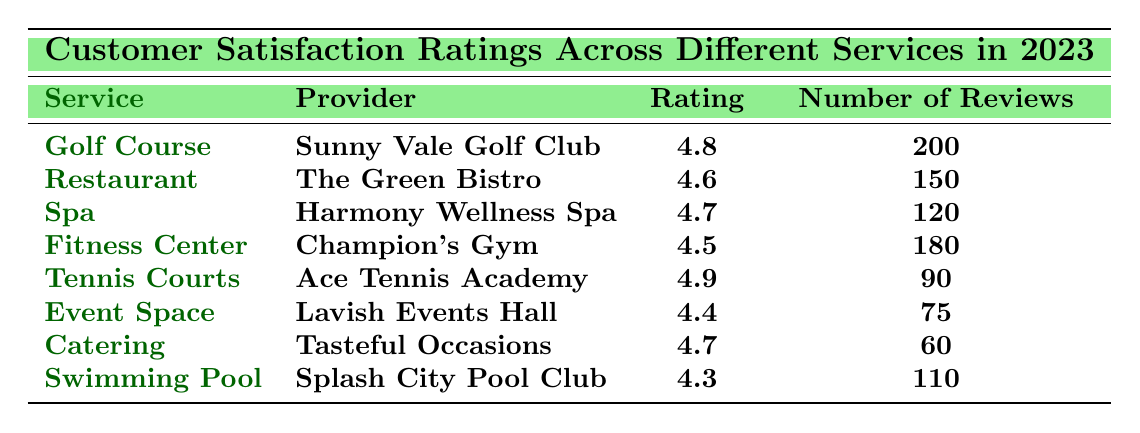What service received the highest satisfaction rating? By reviewing the Ratings column, the highest value is 4.9, which corresponds to the Tennis Courts provided by Ace Tennis Academy.
Answer: Tennis Courts How many reviews were submitted for the Fitness Center? The Number of Reviews column shows that the Fitness Center has 180 reviews.
Answer: 180 Which service had the lowest customer satisfaction rating? The lowest rating in the Ratings column is 4.3, indicating that the Swimming Pool provided by Splash City Pool Club received the least satisfaction.
Answer: Swimming Pool What is the average rating of all services listed in the table? To find the average rating, we sum the ratings (4.8 + 4.6 + 4.7 + 4.5 + 4.9 + 4.4 + 4.7 + 4.3) = 36.9 and divide by the number of services (8). The average rating is 36.9 / 8 = 4.6125.
Answer: 4.6125 Did the Catering service receive a higher or lower rating than the Event Space? The Catering service has a rating of 4.7 while the Event Space has a rating of 4.4. Since 4.7 is greater than 4.4, Catering received a higher rating.
Answer: Higher How many more reviews did the Golf Course receive compared to the Catering service? The Golf Course has 200 reviews and the Catering service has 60 reviews. The difference is 200 - 60 = 140 reviews.
Answer: 140 more reviews What percentage of the total reviews does the Tennis Courts represent? The total number of reviews is 200 + 150 + 120 + 180 + 90 + 75 + 60 + 110 = 1,025. The Tennis Courts received 90 reviews. To find the percentage, (90 / 1025) * 100 ≈ 8.78%.
Answer: Approximately 8.78% Which two services have the same rating? Looking at the Ratings column, both the Spa (4.7) and Catering (4.7) have the same rating.
Answer: Spa and Catering Is the average number of reviews across all services greater than 100? The total number of reviews is 1,025, and there are 8 services. The average is 1,025 / 8 = 128.125, which is greater than 100.
Answer: Yes Which service has a rating closer to 4.5, and what is the exact rating? The Fitness Center has a rating of 4.5. Other services close to it are Restaurant (4.6) and Spa (4.7), but Fitness Center is exactly 4.5.
Answer: Fitness Center, 4.5 